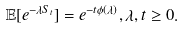<formula> <loc_0><loc_0><loc_500><loc_500>\mathbb { E } [ e ^ { - \lambda S _ { t } } ] = e ^ { - t \phi ( \lambda ) } , \lambda , t \geq 0 .</formula> 